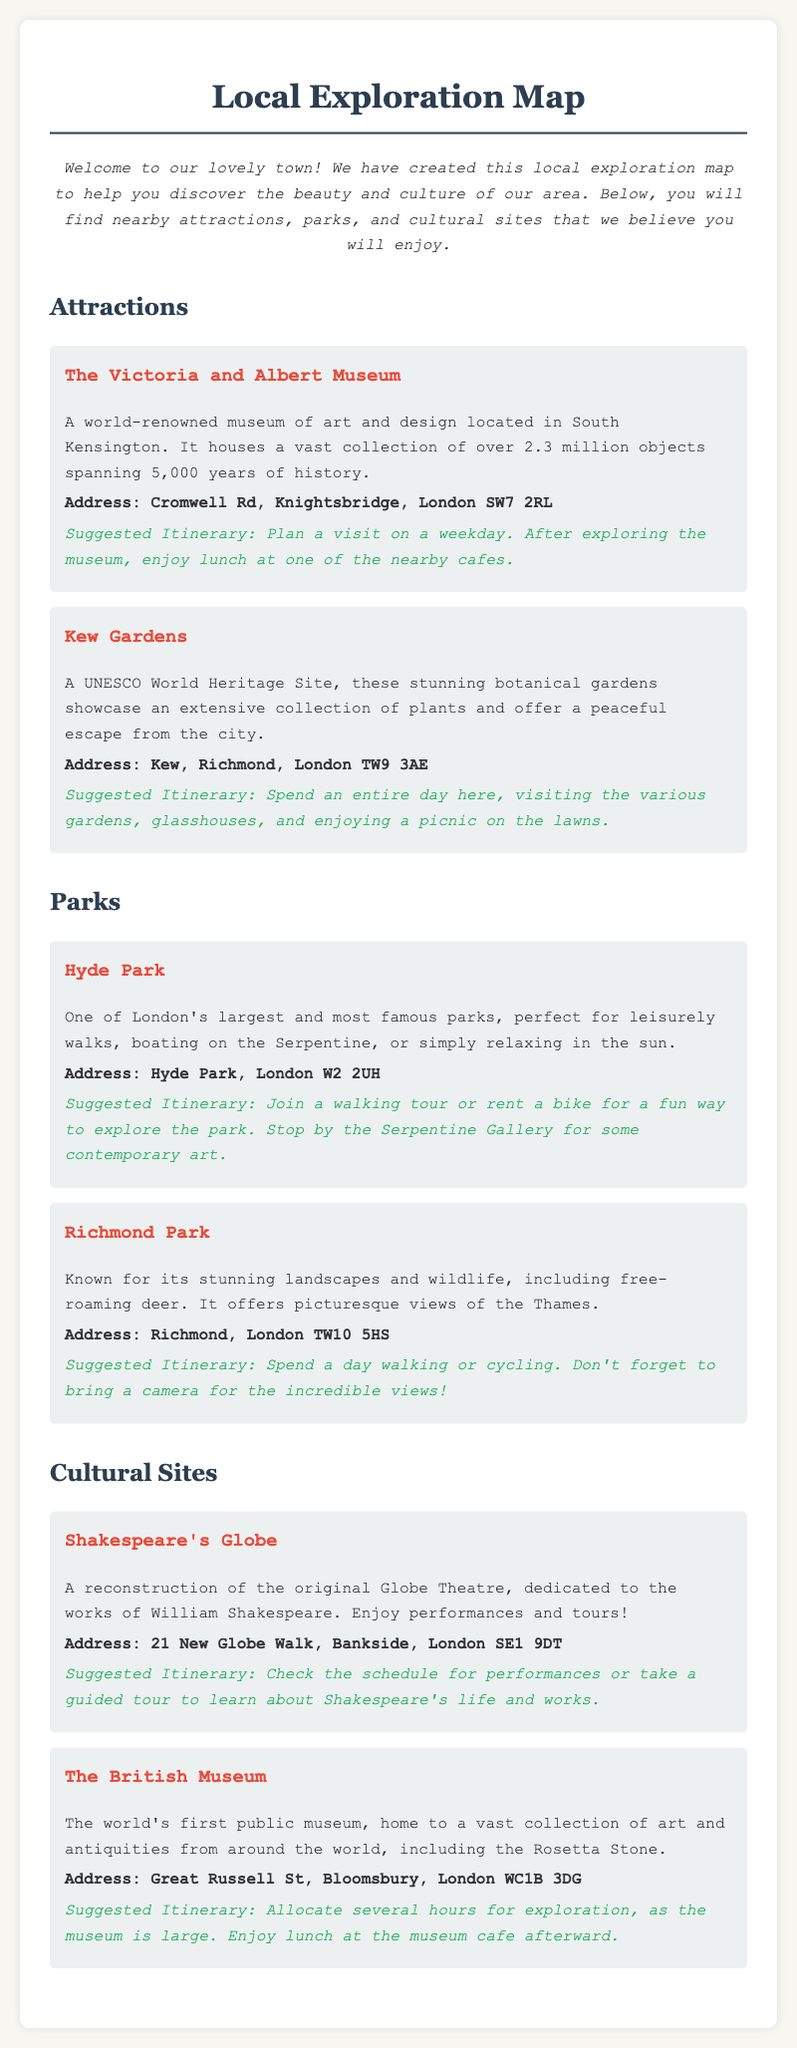What is the address of The Victoria and Albert Museum? The address is detailed in the document under the location section for The Victoria and Albert Museum.
Answer: Cromwell Rd, Knightsbridge, London SW7 2RL What type of museum is The British Museum? The document describes The British Museum as a public museum home to art and antiquities from around the world.
Answer: Public museum What is suggested for a fun way to explore Hyde Park? The itinerary section for Hyde Park provides suggestions for exploring the park, including joining a walking tour or renting a bike.
Answer: Walking tour or renting a bike How many locations are listed under Attractions? The section for Attractions provides information on the number of locations detailed in that section.
Answer: 2 What is the suggested itinerary for Kew Gardens? The itinerary section under Kew Gardens outlines how to spend an entire day visiting various gardens and enjoying a picnic.
Answer: Spend an entire day What notable feature is mentioned about Richmond Park? The document highlights a distinctive characteristic of Richmond Park related to wildlife.
Answer: Free-roaming deer What is the suggested activity at Shakespeare's Globe? The itinerary suggests activities related to performances or tours at Shakespeare's Globe.
Answer: Performances or tours What is the address of Kew Gardens? The address of Kew Gardens is specified in the document under the location section.
Answer: Kew, Richmond, London TW9 3AE 